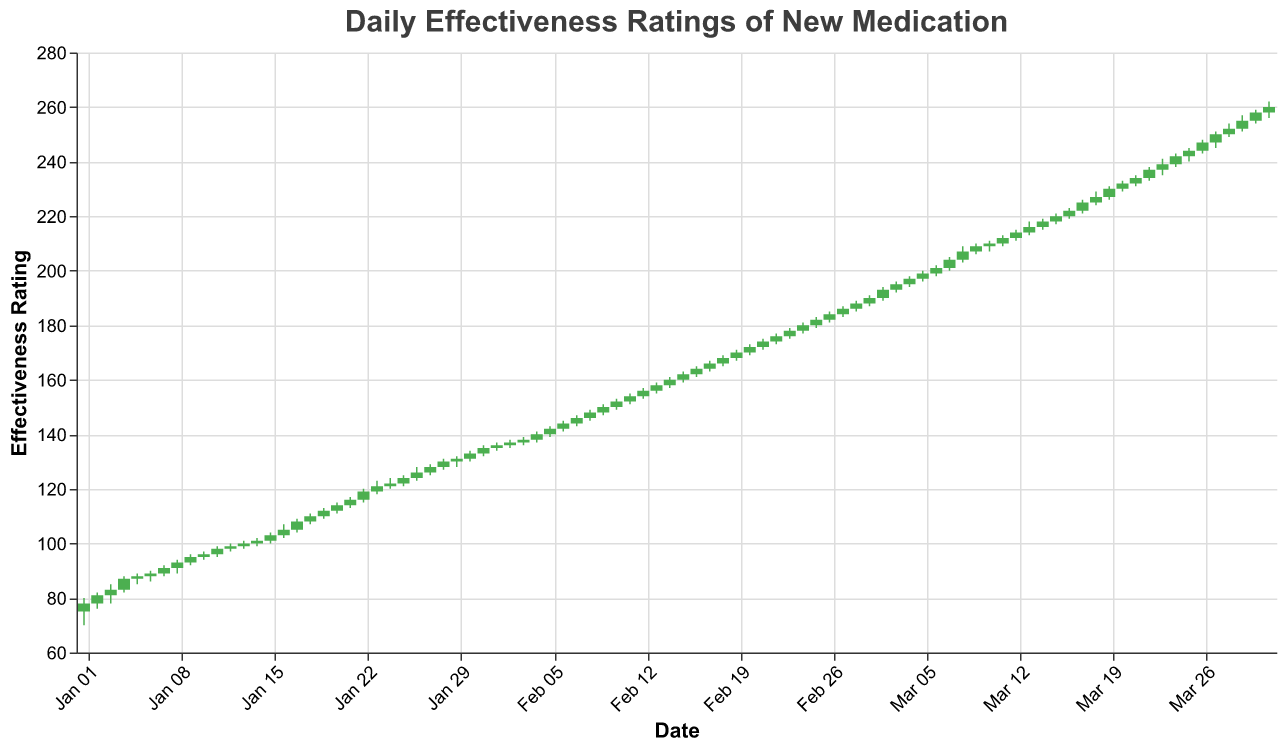What's the title of the figure? The title is prominently displayed at the top of the figure.
Answer: Daily Effectiveness Ratings of New Medication What is the color of the bars indicating an increase in the effectiveness rating? The figure uses different colors to distinguish between increases and decreases, with increases typically shown in green.
Answer: Green On which date did the effectiveness rating reach its highest point? To find the highest point, look for the highest 'High' value on the y-axis. This occurs on March 31, where the 'High' value is 262.
Answer: March 31 How many times did the effectiveness rating close higher than it opened in January? Count the number of days where the 'Close' value is higher than the 'Open' value from January 1 to January 31.
Answer: 21 What's the average effectiveness rating close value of the first week of February? The first week of February includes February 1 to February 7. Sum the 'Close' values for these dates (136, 137, 138, 140, 142, 144, 146) and divide by 7. (136 + 137 + 138 + 140 + 142 + 144 + 146) / 7 = 983 / 7 = 140.43
Answer: 140.43 Which date in March saw the largest single-day increase in the effectiveness rating? To determine this, find the day where the difference between 'Close' and 'Open' is the largest. March 7, with an increase from 201 to 204, seeing a 3-point growth.
Answer: March 7 Did the effectiveness rating ever close lower than it opened in February? Check the 'Close' and 'Open' values for all dates in February. Here, the 'Close' values are always higher or equal to the 'Open' values.
Answer: No On February 14, what was the range (difference) between the high and low effectiveness ratings? The high value on February 14 was 161, and the low value was 157. Calculate the difference: 161 - 157 = 4.
Answer: 4 How many days in March had a 'High' value greater than 240? Count the instances in March where the 'High' value exceeds 240. The dates are March 22, March 23, March 24, March 25, March 26, March 27, March 28, March 29, March 30, and March 31: total 10 days.
Answer: 10 What's the trend in the effectiveness rating from January 1st to January 31st? Examine the daily 'Close' values within January. Visual inspection confirms a consistent upward trend as the values rise from 78 to 135.
Answer: Upward trend 